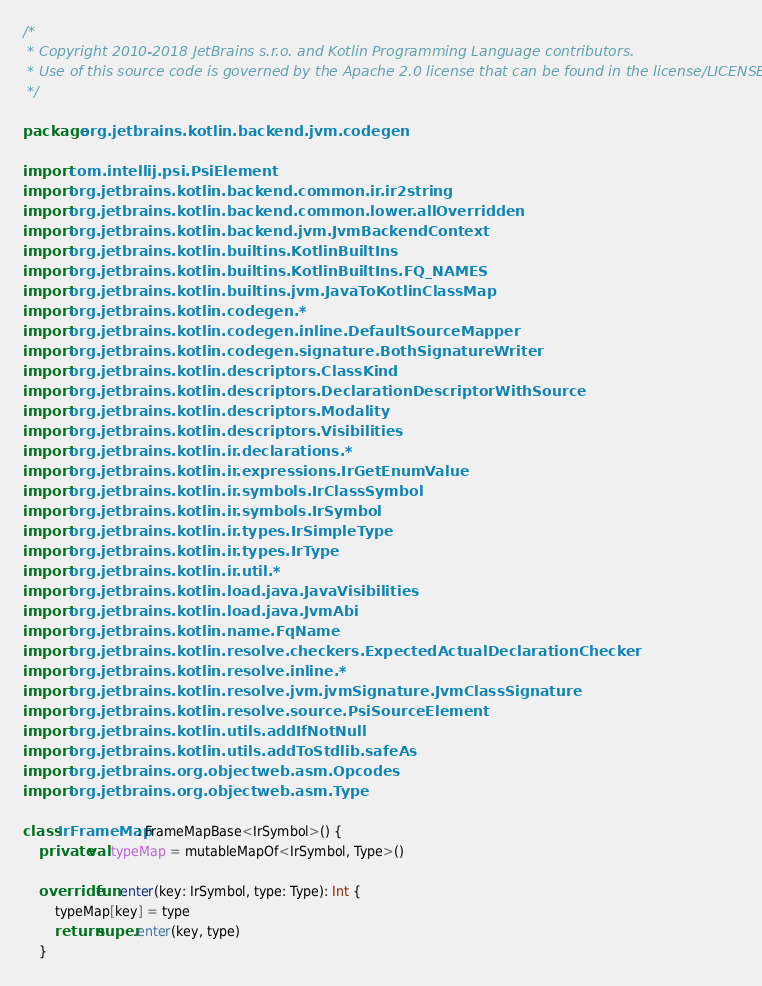Convert code to text. <code><loc_0><loc_0><loc_500><loc_500><_Kotlin_>/*
 * Copyright 2010-2018 JetBrains s.r.o. and Kotlin Programming Language contributors.
 * Use of this source code is governed by the Apache 2.0 license that can be found in the license/LICENSE.txt file.
 */

package org.jetbrains.kotlin.backend.jvm.codegen

import com.intellij.psi.PsiElement
import org.jetbrains.kotlin.backend.common.ir.ir2string
import org.jetbrains.kotlin.backend.common.lower.allOverridden
import org.jetbrains.kotlin.backend.jvm.JvmBackendContext
import org.jetbrains.kotlin.builtins.KotlinBuiltIns
import org.jetbrains.kotlin.builtins.KotlinBuiltIns.FQ_NAMES
import org.jetbrains.kotlin.builtins.jvm.JavaToKotlinClassMap
import org.jetbrains.kotlin.codegen.*
import org.jetbrains.kotlin.codegen.inline.DefaultSourceMapper
import org.jetbrains.kotlin.codegen.signature.BothSignatureWriter
import org.jetbrains.kotlin.descriptors.ClassKind
import org.jetbrains.kotlin.descriptors.DeclarationDescriptorWithSource
import org.jetbrains.kotlin.descriptors.Modality
import org.jetbrains.kotlin.descriptors.Visibilities
import org.jetbrains.kotlin.ir.declarations.*
import org.jetbrains.kotlin.ir.expressions.IrGetEnumValue
import org.jetbrains.kotlin.ir.symbols.IrClassSymbol
import org.jetbrains.kotlin.ir.symbols.IrSymbol
import org.jetbrains.kotlin.ir.types.IrSimpleType
import org.jetbrains.kotlin.ir.types.IrType
import org.jetbrains.kotlin.ir.util.*
import org.jetbrains.kotlin.load.java.JavaVisibilities
import org.jetbrains.kotlin.load.java.JvmAbi
import org.jetbrains.kotlin.name.FqName
import org.jetbrains.kotlin.resolve.checkers.ExpectedActualDeclarationChecker
import org.jetbrains.kotlin.resolve.inline.*
import org.jetbrains.kotlin.resolve.jvm.jvmSignature.JvmClassSignature
import org.jetbrains.kotlin.resolve.source.PsiSourceElement
import org.jetbrains.kotlin.utils.addIfNotNull
import org.jetbrains.kotlin.utils.addToStdlib.safeAs
import org.jetbrains.org.objectweb.asm.Opcodes
import org.jetbrains.org.objectweb.asm.Type

class IrFrameMap : FrameMapBase<IrSymbol>() {
    private val typeMap = mutableMapOf<IrSymbol, Type>()

    override fun enter(key: IrSymbol, type: Type): Int {
        typeMap[key] = type
        return super.enter(key, type)
    }
</code> 